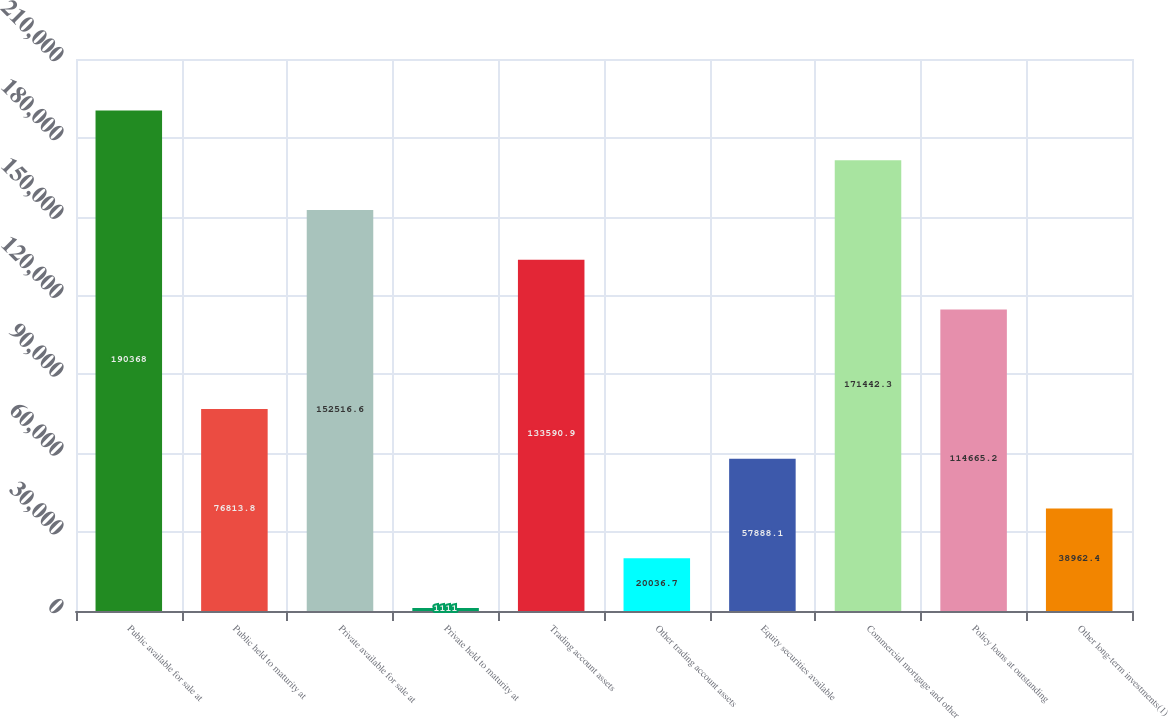Convert chart. <chart><loc_0><loc_0><loc_500><loc_500><bar_chart><fcel>Public available for sale at<fcel>Public held to maturity at<fcel>Private available for sale at<fcel>Private held to maturity at<fcel>Trading account assets<fcel>Other trading account assets<fcel>Equity securities available<fcel>Commercial mortgage and other<fcel>Policy loans at outstanding<fcel>Other long-term investments(1)<nl><fcel>190368<fcel>76813.8<fcel>152517<fcel>1111<fcel>133591<fcel>20036.7<fcel>57888.1<fcel>171442<fcel>114665<fcel>38962.4<nl></chart> 